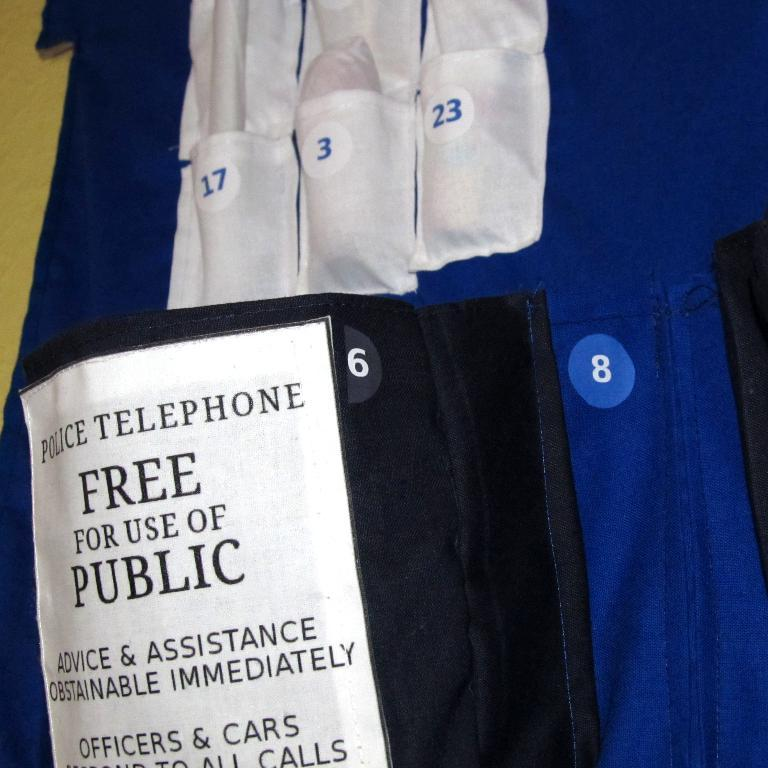<image>
Write a terse but informative summary of the picture. a pocket with a notice on it that says 'police telephone' 